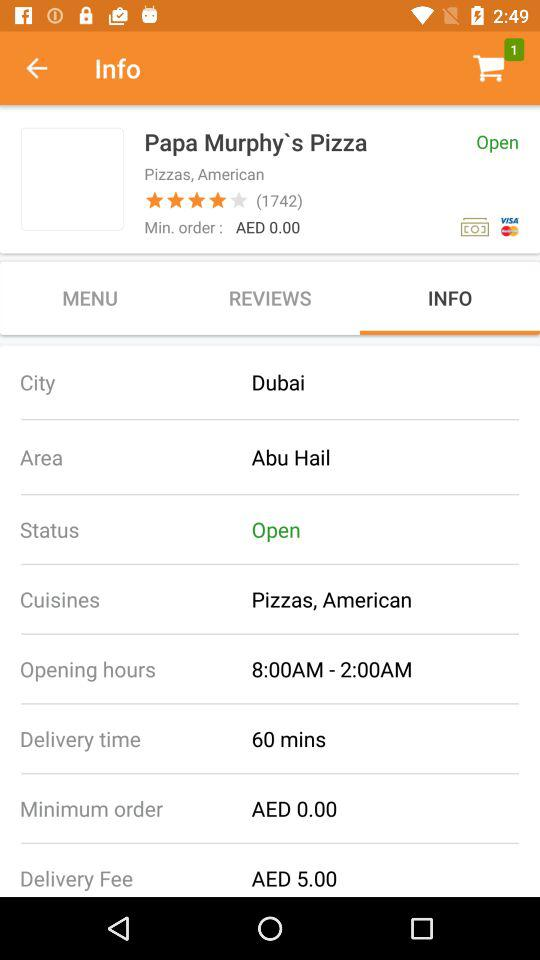What is the delivery time? The delivery time is 60 minutes. 